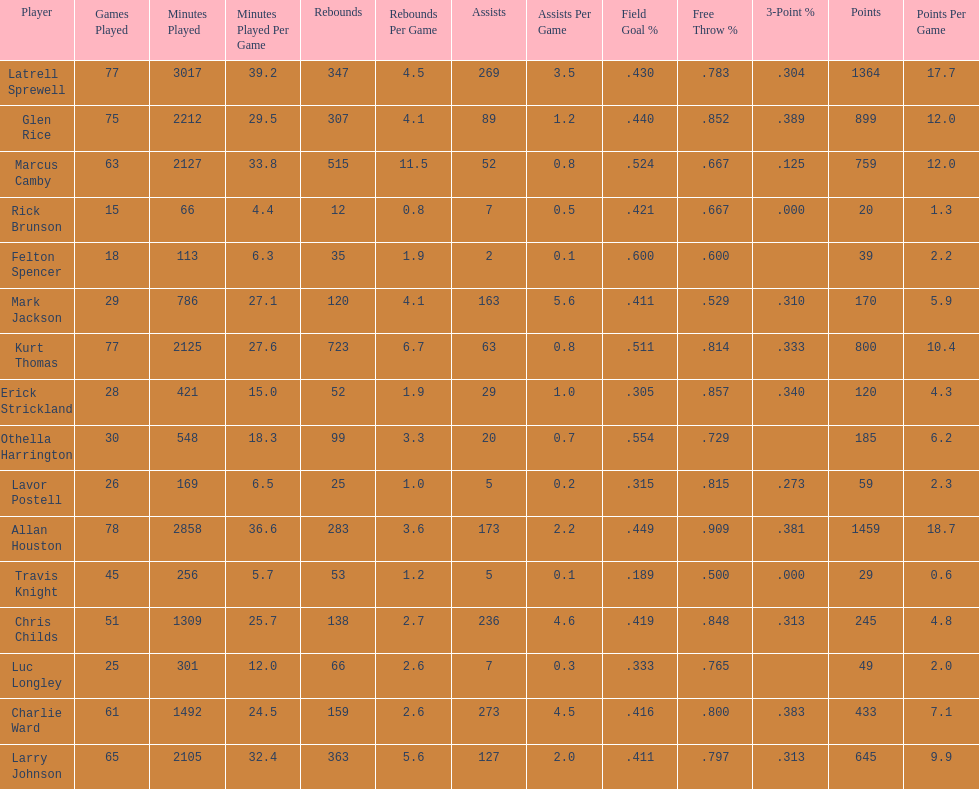Number of players on the team. 16. 